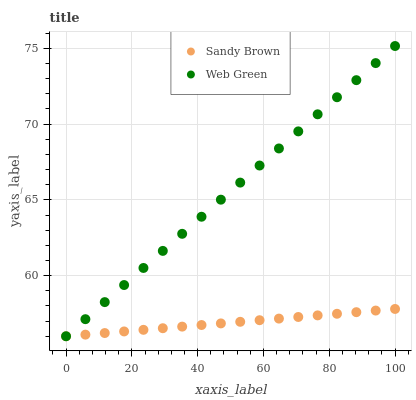Does Sandy Brown have the minimum area under the curve?
Answer yes or no. Yes. Does Web Green have the maximum area under the curve?
Answer yes or no. Yes. Does Web Green have the minimum area under the curve?
Answer yes or no. No. Is Sandy Brown the smoothest?
Answer yes or no. Yes. Is Web Green the roughest?
Answer yes or no. Yes. Is Web Green the smoothest?
Answer yes or no. No. Does Sandy Brown have the lowest value?
Answer yes or no. Yes. Does Web Green have the highest value?
Answer yes or no. Yes. Does Web Green intersect Sandy Brown?
Answer yes or no. Yes. Is Web Green less than Sandy Brown?
Answer yes or no. No. Is Web Green greater than Sandy Brown?
Answer yes or no. No. 